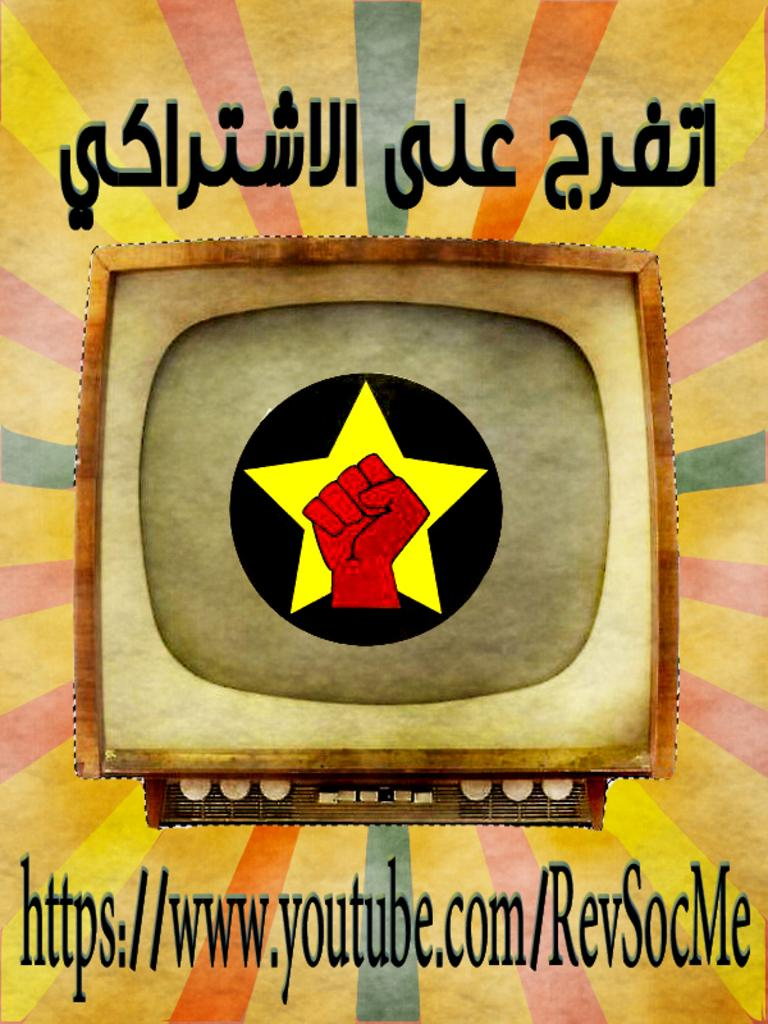What is the main subject of the image? There is a depiction of a television in the image. What else can be seen on the television? There are logos visible in the image. What type of information is present on the television? There is text written at various places in the image. What can be observed about the background of the image? The background of the image contains different colors. How does the television provide comfort to the viewers in the image? The image does not depict viewers or any interaction with the television, so it cannot be determined how the television provides comfort. 